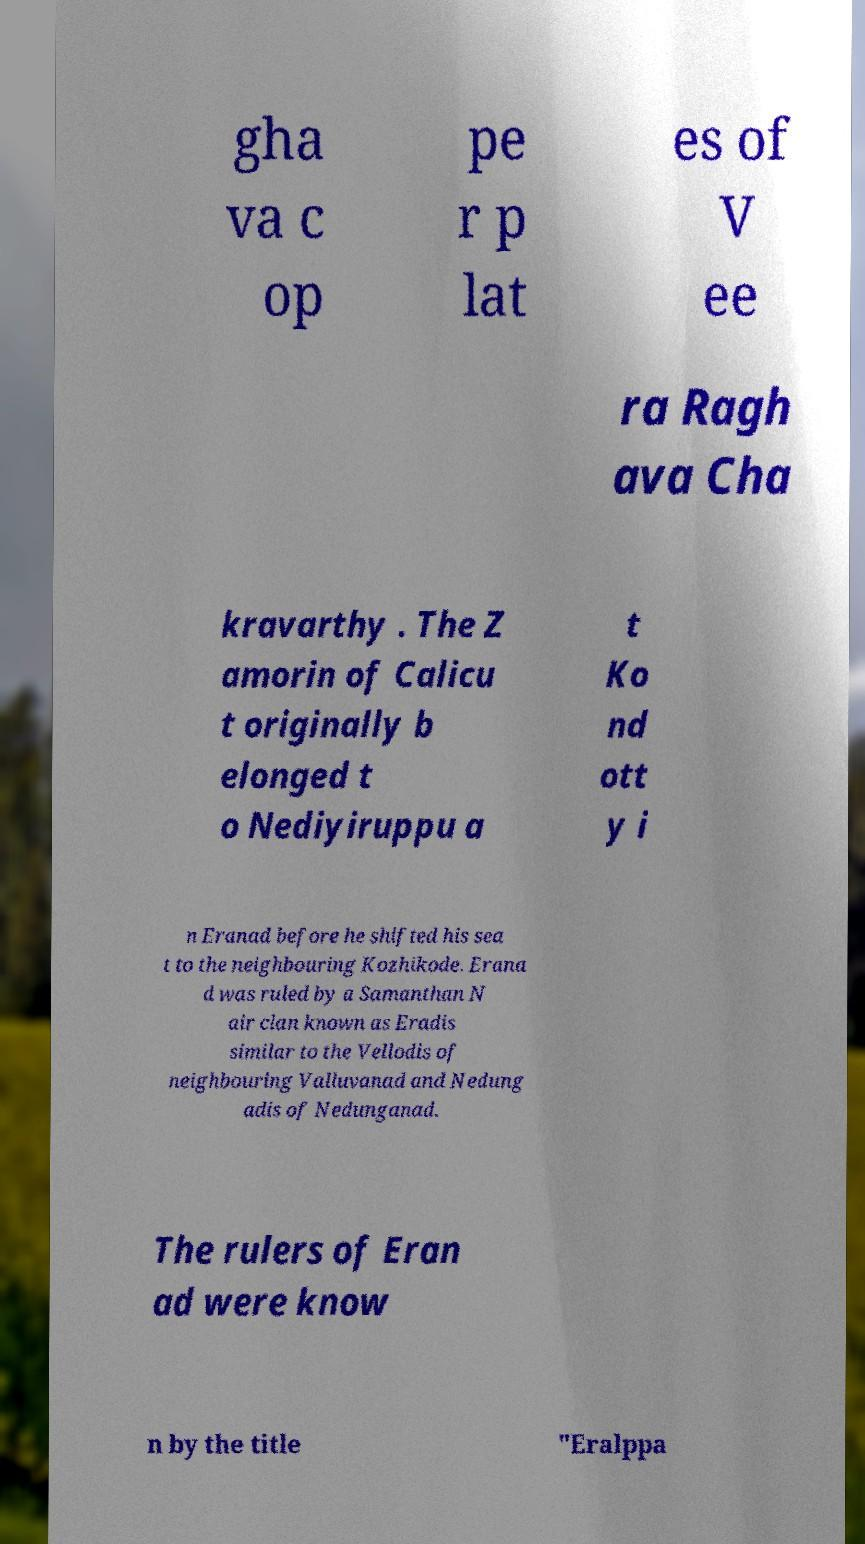There's text embedded in this image that I need extracted. Can you transcribe it verbatim? gha va c op pe r p lat es of V ee ra Ragh ava Cha kravarthy . The Z amorin of Calicu t originally b elonged t o Nediyiruppu a t Ko nd ott y i n Eranad before he shifted his sea t to the neighbouring Kozhikode. Erana d was ruled by a Samanthan N air clan known as Eradis similar to the Vellodis of neighbouring Valluvanad and Nedung adis of Nedunganad. The rulers of Eran ad were know n by the title "Eralppa 